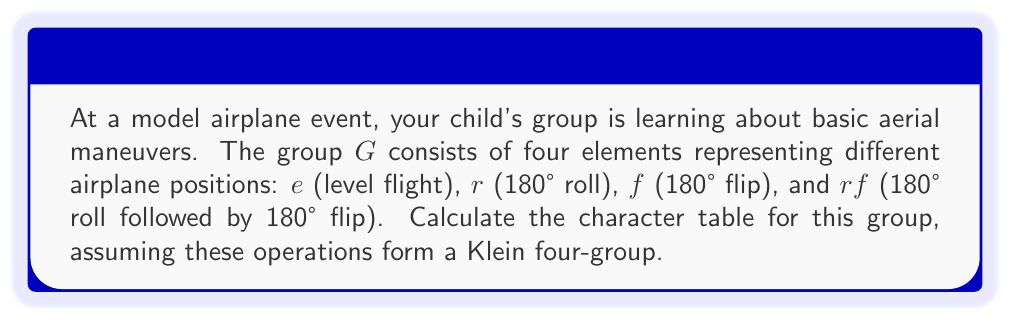Teach me how to tackle this problem. To calculate the character table for this Klein four-group, we'll follow these steps:

1) First, identify the conjugacy classes. In a Klein four-group, each element forms its own conjugacy class: $\{e\}$, $\{r\}$, $\{f\}$, and $\{rf\}$.

2) The number of irreducible representations equals the number of conjugacy classes, so we have 4 irreducible representations.

3) For an abelian group, all irreducible representations are 1-dimensional. The character table will be a 4x4 matrix.

4) The first row of the character table always corresponds to the trivial representation, which maps every element to 1.

5) For the remaining rows, we need to ensure orthogonality. We can use the fact that for a Klein four-group, each non-identity element has order 2.

6) The character table will have the following form:

   $$\begin{array}{c|cccc}
    G & e & r & f & rf \\
    \hline
    \chi_1 & 1 & 1 & 1 & 1 \\
    \chi_2 & 1 & 1 & -1 & -1 \\
    \chi_3 & 1 & -1 & 1 & -1 \\
    \chi_4 & 1 & -1 & -1 & 1
   \end{array}$$

7) Verify orthogonality: The inner product of any two distinct rows is zero, and the inner product of any row with itself is equal to the order of the group (4).

This character table completely describes the irreducible representations of the group representing the airplane maneuvers.
Answer: $$\begin{array}{c|cccc}
G & e & r & f & rf \\
\hline
\chi_1 & 1 & 1 & 1 & 1 \\
\chi_2 & 1 & 1 & -1 & -1 \\
\chi_3 & 1 & -1 & 1 & -1 \\
\chi_4 & 1 & -1 & -1 & 1
\end{array}$$ 